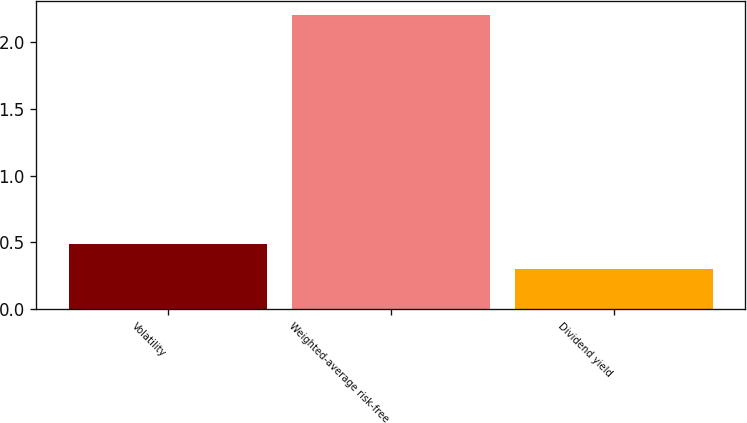Convert chart. <chart><loc_0><loc_0><loc_500><loc_500><bar_chart><fcel>Volatility<fcel>Weighted-average risk-free<fcel>Dividend yield<nl><fcel>0.49<fcel>2.2<fcel>0.3<nl></chart> 